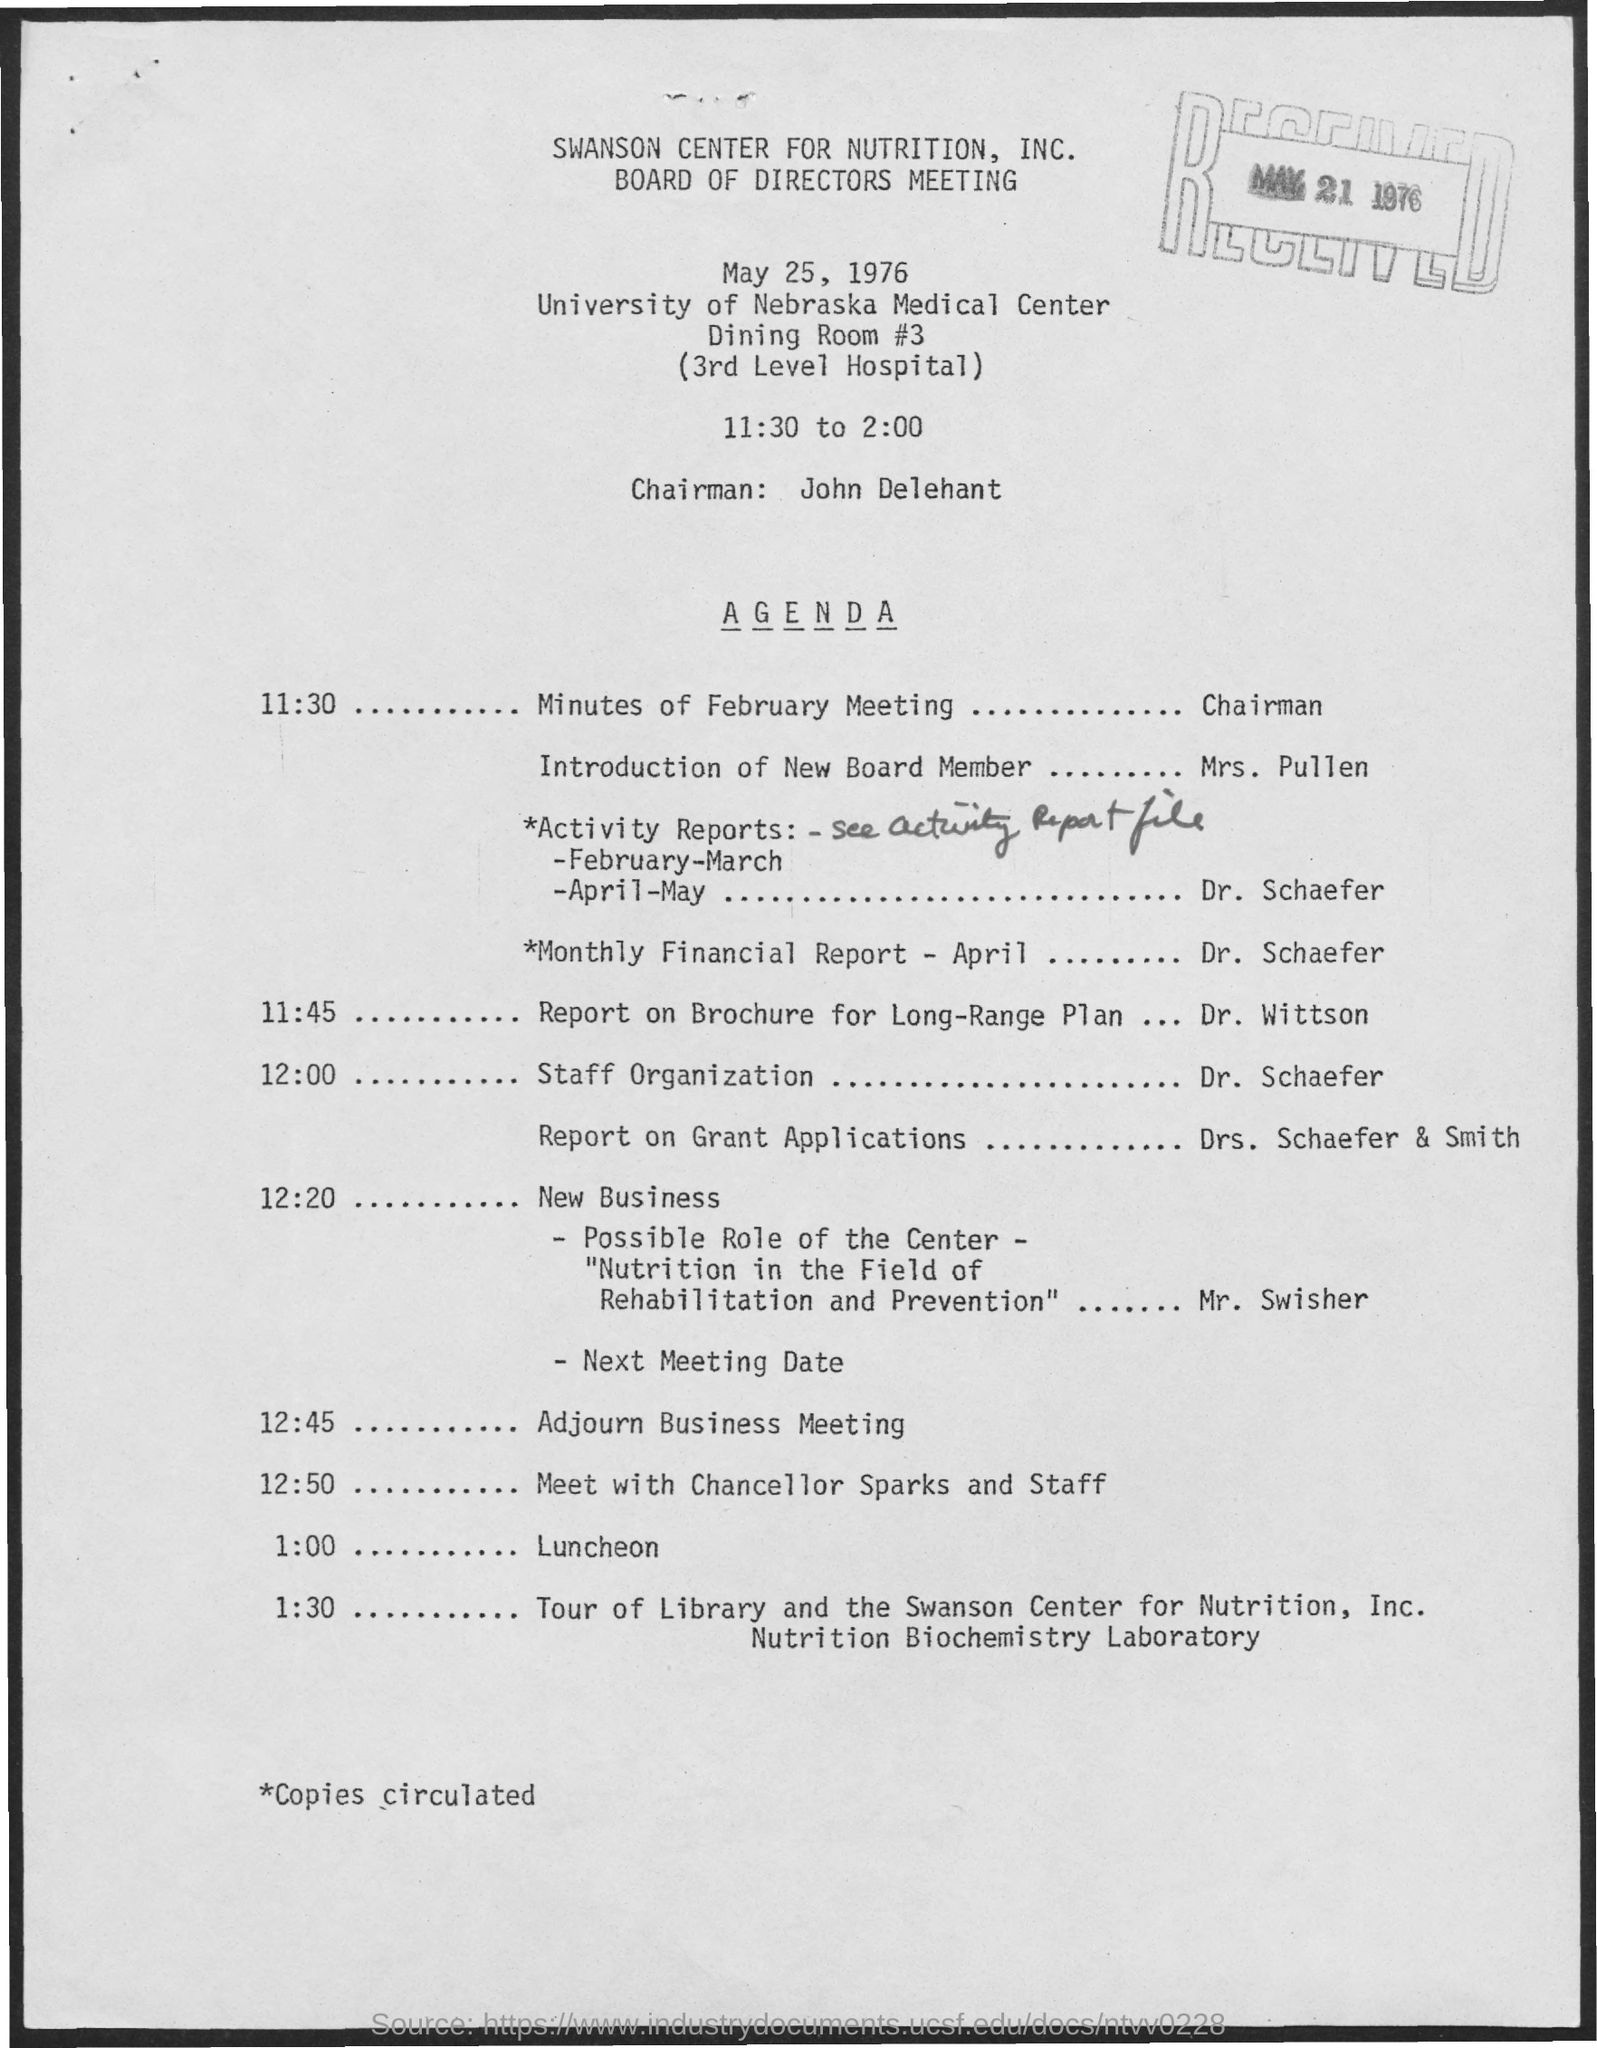What is the name of the meeting ?
Ensure brevity in your answer.  Board of directors meeting. What is the date mentioned in the given page ?
Offer a terse response. May 25, 1976. What is the time mentioned ?
Provide a short and direct response. 11:30 to 2:00. What is the name of the chairman mentioned ?
Make the answer very short. John delehant. What is the received date mentioned ?
Give a very brief answer. May 21 1976. 